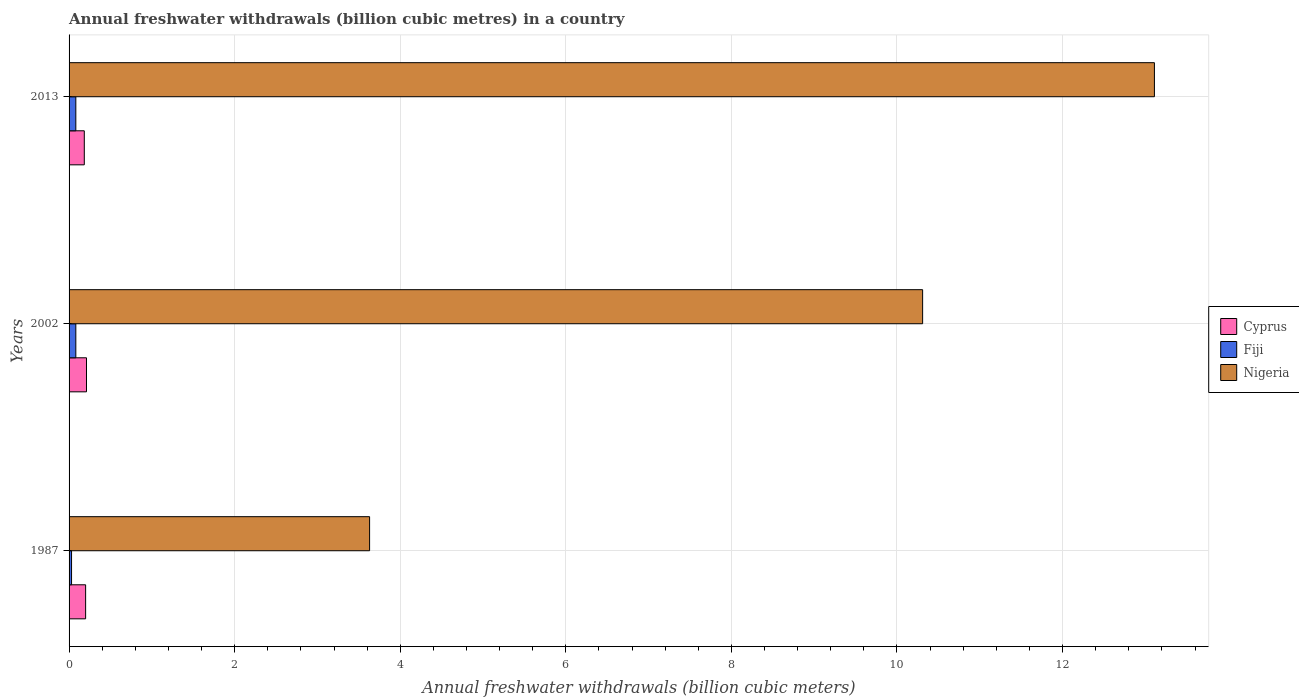How many groups of bars are there?
Keep it short and to the point. 3. How many bars are there on the 1st tick from the bottom?
Your answer should be compact. 3. What is the label of the 2nd group of bars from the top?
Provide a short and direct response. 2002. In how many cases, is the number of bars for a given year not equal to the number of legend labels?
Ensure brevity in your answer.  0. What is the annual freshwater withdrawals in Cyprus in 1987?
Your answer should be compact. 0.2. Across all years, what is the maximum annual freshwater withdrawals in Cyprus?
Your answer should be compact. 0.21. Across all years, what is the minimum annual freshwater withdrawals in Cyprus?
Ensure brevity in your answer.  0.18. In which year was the annual freshwater withdrawals in Cyprus maximum?
Ensure brevity in your answer.  2002. What is the total annual freshwater withdrawals in Nigeria in the graph?
Your answer should be very brief. 27.05. What is the difference between the annual freshwater withdrawals in Cyprus in 2002 and that in 2013?
Your answer should be very brief. 0.03. What is the difference between the annual freshwater withdrawals in Cyprus in 2013 and the annual freshwater withdrawals in Nigeria in 2002?
Provide a short and direct response. -10.13. What is the average annual freshwater withdrawals in Cyprus per year?
Your answer should be very brief. 0.2. In the year 2002, what is the difference between the annual freshwater withdrawals in Cyprus and annual freshwater withdrawals in Fiji?
Your answer should be compact. 0.13. In how many years, is the annual freshwater withdrawals in Fiji greater than 3.2 billion cubic meters?
Offer a terse response. 0. What is the ratio of the annual freshwater withdrawals in Nigeria in 1987 to that in 2013?
Ensure brevity in your answer.  0.28. What is the difference between the highest and the second highest annual freshwater withdrawals in Nigeria?
Your answer should be compact. 2.8. What is the difference between the highest and the lowest annual freshwater withdrawals in Cyprus?
Keep it short and to the point. 0.03. In how many years, is the annual freshwater withdrawals in Nigeria greater than the average annual freshwater withdrawals in Nigeria taken over all years?
Provide a succinct answer. 2. Is the sum of the annual freshwater withdrawals in Nigeria in 2002 and 2013 greater than the maximum annual freshwater withdrawals in Cyprus across all years?
Provide a short and direct response. Yes. What does the 2nd bar from the top in 1987 represents?
Give a very brief answer. Fiji. What does the 1st bar from the bottom in 2002 represents?
Offer a terse response. Cyprus. Is it the case that in every year, the sum of the annual freshwater withdrawals in Nigeria and annual freshwater withdrawals in Cyprus is greater than the annual freshwater withdrawals in Fiji?
Your answer should be very brief. Yes. How many bars are there?
Offer a very short reply. 9. How many years are there in the graph?
Your response must be concise. 3. What is the title of the graph?
Ensure brevity in your answer.  Annual freshwater withdrawals (billion cubic metres) in a country. What is the label or title of the X-axis?
Ensure brevity in your answer.  Annual freshwater withdrawals (billion cubic meters). What is the label or title of the Y-axis?
Offer a terse response. Years. What is the Annual freshwater withdrawals (billion cubic meters) of Cyprus in 1987?
Give a very brief answer. 0.2. What is the Annual freshwater withdrawals (billion cubic meters) in Fiji in 1987?
Offer a very short reply. 0.03. What is the Annual freshwater withdrawals (billion cubic meters) of Nigeria in 1987?
Ensure brevity in your answer.  3.63. What is the Annual freshwater withdrawals (billion cubic meters) in Cyprus in 2002?
Make the answer very short. 0.21. What is the Annual freshwater withdrawals (billion cubic meters) in Fiji in 2002?
Provide a short and direct response. 0.08. What is the Annual freshwater withdrawals (billion cubic meters) of Nigeria in 2002?
Your answer should be compact. 10.31. What is the Annual freshwater withdrawals (billion cubic meters) in Cyprus in 2013?
Ensure brevity in your answer.  0.18. What is the Annual freshwater withdrawals (billion cubic meters) of Fiji in 2013?
Provide a short and direct response. 0.08. What is the Annual freshwater withdrawals (billion cubic meters) of Nigeria in 2013?
Your answer should be compact. 13.11. Across all years, what is the maximum Annual freshwater withdrawals (billion cubic meters) of Cyprus?
Provide a succinct answer. 0.21. Across all years, what is the maximum Annual freshwater withdrawals (billion cubic meters) in Fiji?
Provide a succinct answer. 0.08. Across all years, what is the maximum Annual freshwater withdrawals (billion cubic meters) of Nigeria?
Your answer should be very brief. 13.11. Across all years, what is the minimum Annual freshwater withdrawals (billion cubic meters) of Cyprus?
Your answer should be compact. 0.18. Across all years, what is the minimum Annual freshwater withdrawals (billion cubic meters) in Fiji?
Provide a succinct answer. 0.03. Across all years, what is the minimum Annual freshwater withdrawals (billion cubic meters) in Nigeria?
Give a very brief answer. 3.63. What is the total Annual freshwater withdrawals (billion cubic meters) in Cyprus in the graph?
Make the answer very short. 0.59. What is the total Annual freshwater withdrawals (billion cubic meters) of Fiji in the graph?
Ensure brevity in your answer.  0.19. What is the total Annual freshwater withdrawals (billion cubic meters) in Nigeria in the graph?
Offer a very short reply. 27.05. What is the difference between the Annual freshwater withdrawals (billion cubic meters) of Cyprus in 1987 and that in 2002?
Give a very brief answer. -0.01. What is the difference between the Annual freshwater withdrawals (billion cubic meters) in Fiji in 1987 and that in 2002?
Make the answer very short. -0.05. What is the difference between the Annual freshwater withdrawals (billion cubic meters) in Nigeria in 1987 and that in 2002?
Make the answer very short. -6.68. What is the difference between the Annual freshwater withdrawals (billion cubic meters) of Cyprus in 1987 and that in 2013?
Make the answer very short. 0.02. What is the difference between the Annual freshwater withdrawals (billion cubic meters) in Fiji in 1987 and that in 2013?
Your answer should be very brief. -0.05. What is the difference between the Annual freshwater withdrawals (billion cubic meters) of Nigeria in 1987 and that in 2013?
Provide a succinct answer. -9.48. What is the difference between the Annual freshwater withdrawals (billion cubic meters) of Cyprus in 2002 and that in 2013?
Keep it short and to the point. 0.03. What is the difference between the Annual freshwater withdrawals (billion cubic meters) of Nigeria in 2002 and that in 2013?
Keep it short and to the point. -2.8. What is the difference between the Annual freshwater withdrawals (billion cubic meters) in Cyprus in 1987 and the Annual freshwater withdrawals (billion cubic meters) in Fiji in 2002?
Offer a terse response. 0.12. What is the difference between the Annual freshwater withdrawals (billion cubic meters) of Cyprus in 1987 and the Annual freshwater withdrawals (billion cubic meters) of Nigeria in 2002?
Your answer should be very brief. -10.11. What is the difference between the Annual freshwater withdrawals (billion cubic meters) in Fiji in 1987 and the Annual freshwater withdrawals (billion cubic meters) in Nigeria in 2002?
Your answer should be compact. -10.28. What is the difference between the Annual freshwater withdrawals (billion cubic meters) in Cyprus in 1987 and the Annual freshwater withdrawals (billion cubic meters) in Fiji in 2013?
Ensure brevity in your answer.  0.12. What is the difference between the Annual freshwater withdrawals (billion cubic meters) of Cyprus in 1987 and the Annual freshwater withdrawals (billion cubic meters) of Nigeria in 2013?
Your answer should be compact. -12.91. What is the difference between the Annual freshwater withdrawals (billion cubic meters) of Fiji in 1987 and the Annual freshwater withdrawals (billion cubic meters) of Nigeria in 2013?
Offer a very short reply. -13.08. What is the difference between the Annual freshwater withdrawals (billion cubic meters) of Cyprus in 2002 and the Annual freshwater withdrawals (billion cubic meters) of Fiji in 2013?
Provide a succinct answer. 0.13. What is the difference between the Annual freshwater withdrawals (billion cubic meters) of Cyprus in 2002 and the Annual freshwater withdrawals (billion cubic meters) of Nigeria in 2013?
Offer a terse response. -12.9. What is the difference between the Annual freshwater withdrawals (billion cubic meters) in Fiji in 2002 and the Annual freshwater withdrawals (billion cubic meters) in Nigeria in 2013?
Provide a short and direct response. -13.03. What is the average Annual freshwater withdrawals (billion cubic meters) in Cyprus per year?
Your answer should be very brief. 0.2. What is the average Annual freshwater withdrawals (billion cubic meters) of Fiji per year?
Provide a succinct answer. 0.06. What is the average Annual freshwater withdrawals (billion cubic meters) in Nigeria per year?
Provide a succinct answer. 9.02. In the year 1987, what is the difference between the Annual freshwater withdrawals (billion cubic meters) of Cyprus and Annual freshwater withdrawals (billion cubic meters) of Fiji?
Your response must be concise. 0.17. In the year 1987, what is the difference between the Annual freshwater withdrawals (billion cubic meters) of Cyprus and Annual freshwater withdrawals (billion cubic meters) of Nigeria?
Keep it short and to the point. -3.43. In the year 2002, what is the difference between the Annual freshwater withdrawals (billion cubic meters) of Cyprus and Annual freshwater withdrawals (billion cubic meters) of Fiji?
Your response must be concise. 0.13. In the year 2002, what is the difference between the Annual freshwater withdrawals (billion cubic meters) in Cyprus and Annual freshwater withdrawals (billion cubic meters) in Nigeria?
Offer a very short reply. -10.1. In the year 2002, what is the difference between the Annual freshwater withdrawals (billion cubic meters) of Fiji and Annual freshwater withdrawals (billion cubic meters) of Nigeria?
Give a very brief answer. -10.23. In the year 2013, what is the difference between the Annual freshwater withdrawals (billion cubic meters) of Cyprus and Annual freshwater withdrawals (billion cubic meters) of Fiji?
Keep it short and to the point. 0.1. In the year 2013, what is the difference between the Annual freshwater withdrawals (billion cubic meters) of Cyprus and Annual freshwater withdrawals (billion cubic meters) of Nigeria?
Your answer should be very brief. -12.93. In the year 2013, what is the difference between the Annual freshwater withdrawals (billion cubic meters) in Fiji and Annual freshwater withdrawals (billion cubic meters) in Nigeria?
Offer a very short reply. -13.03. What is the ratio of the Annual freshwater withdrawals (billion cubic meters) of Cyprus in 1987 to that in 2002?
Provide a short and direct response. 0.95. What is the ratio of the Annual freshwater withdrawals (billion cubic meters) in Fiji in 1987 to that in 2002?
Ensure brevity in your answer.  0.37. What is the ratio of the Annual freshwater withdrawals (billion cubic meters) in Nigeria in 1987 to that in 2002?
Give a very brief answer. 0.35. What is the ratio of the Annual freshwater withdrawals (billion cubic meters) of Cyprus in 1987 to that in 2013?
Offer a very short reply. 1.09. What is the ratio of the Annual freshwater withdrawals (billion cubic meters) of Fiji in 1987 to that in 2013?
Give a very brief answer. 0.37. What is the ratio of the Annual freshwater withdrawals (billion cubic meters) in Nigeria in 1987 to that in 2013?
Provide a short and direct response. 0.28. What is the ratio of the Annual freshwater withdrawals (billion cubic meters) in Cyprus in 2002 to that in 2013?
Your answer should be compact. 1.14. What is the ratio of the Annual freshwater withdrawals (billion cubic meters) of Nigeria in 2002 to that in 2013?
Ensure brevity in your answer.  0.79. What is the difference between the highest and the second highest Annual freshwater withdrawals (billion cubic meters) in Cyprus?
Make the answer very short. 0.01. What is the difference between the highest and the lowest Annual freshwater withdrawals (billion cubic meters) in Cyprus?
Provide a succinct answer. 0.03. What is the difference between the highest and the lowest Annual freshwater withdrawals (billion cubic meters) of Fiji?
Give a very brief answer. 0.05. What is the difference between the highest and the lowest Annual freshwater withdrawals (billion cubic meters) in Nigeria?
Your response must be concise. 9.48. 